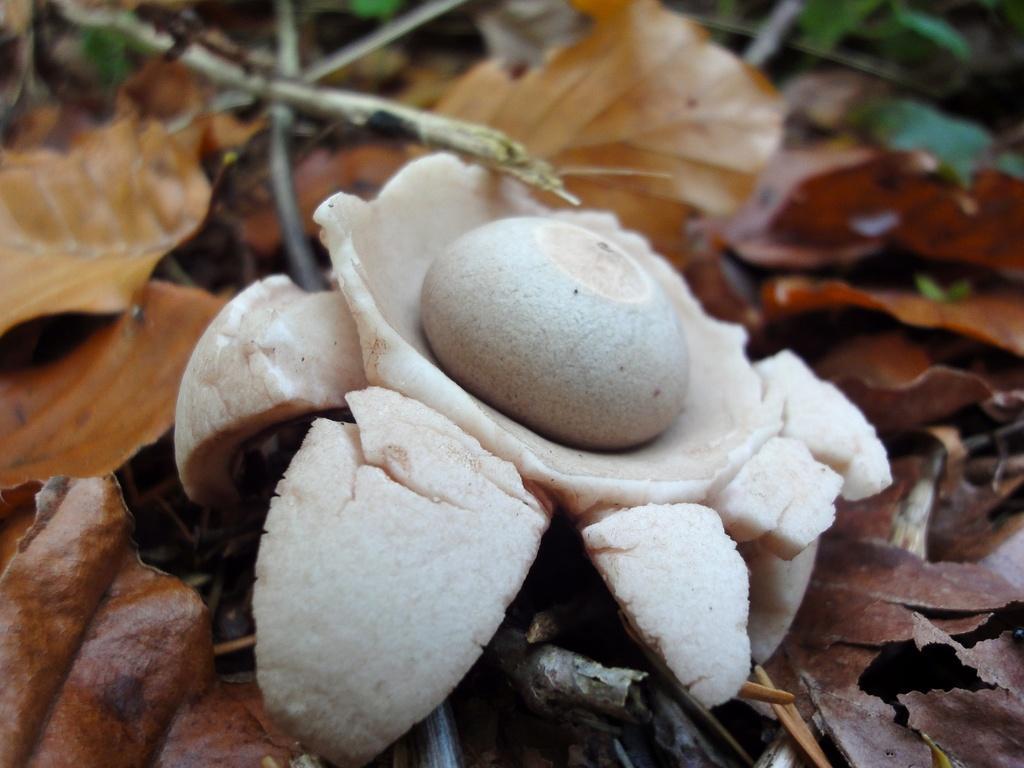Describe this image in one or two sentences. In this image there is a white colour object on the dried leaves. 